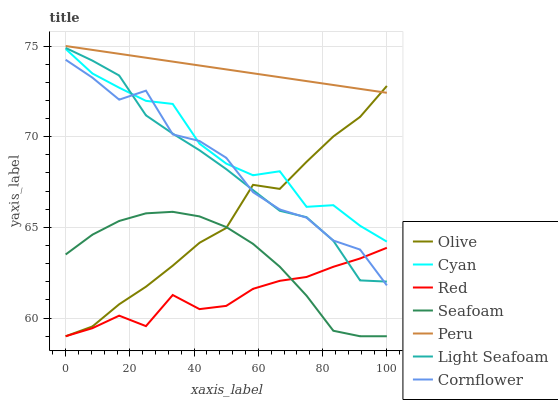Does Red have the minimum area under the curve?
Answer yes or no. Yes. Does Peru have the maximum area under the curve?
Answer yes or no. Yes. Does Seafoam have the minimum area under the curve?
Answer yes or no. No. Does Seafoam have the maximum area under the curve?
Answer yes or no. No. Is Peru the smoothest?
Answer yes or no. Yes. Is Cornflower the roughest?
Answer yes or no. Yes. Is Seafoam the smoothest?
Answer yes or no. No. Is Seafoam the roughest?
Answer yes or no. No. Does Seafoam have the lowest value?
Answer yes or no. Yes. Does Peru have the lowest value?
Answer yes or no. No. Does Peru have the highest value?
Answer yes or no. Yes. Does Seafoam have the highest value?
Answer yes or no. No. Is Cornflower less than Peru?
Answer yes or no. Yes. Is Peru greater than Light Seafoam?
Answer yes or no. Yes. Does Red intersect Olive?
Answer yes or no. Yes. Is Red less than Olive?
Answer yes or no. No. Is Red greater than Olive?
Answer yes or no. No. Does Cornflower intersect Peru?
Answer yes or no. No. 